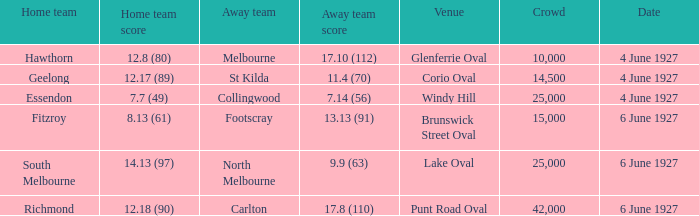Which venue's home team is geelong? Corio Oval. 